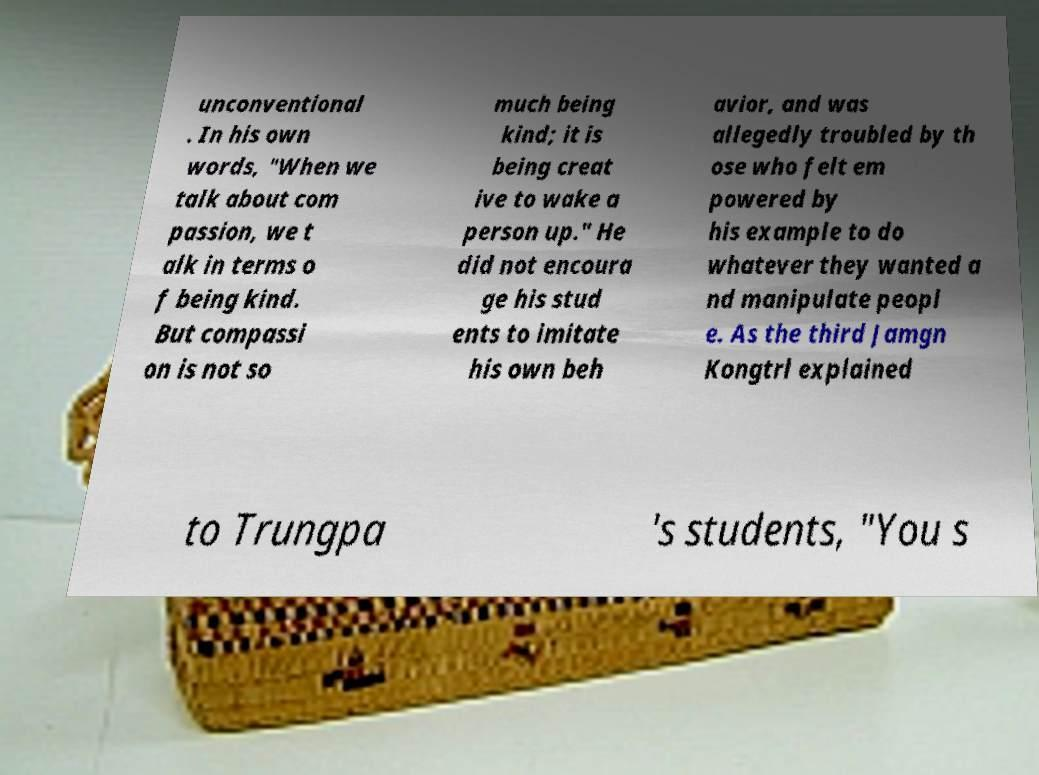What messages or text are displayed in this image? I need them in a readable, typed format. unconventional . In his own words, "When we talk about com passion, we t alk in terms o f being kind. But compassi on is not so much being kind; it is being creat ive to wake a person up." He did not encoura ge his stud ents to imitate his own beh avior, and was allegedly troubled by th ose who felt em powered by his example to do whatever they wanted a nd manipulate peopl e. As the third Jamgn Kongtrl explained to Trungpa 's students, "You s 